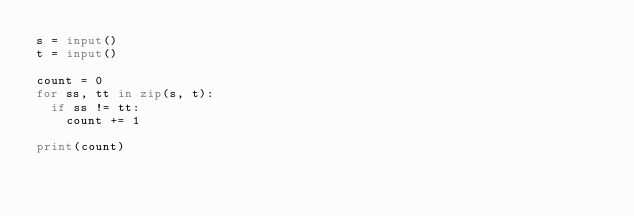Convert code to text. <code><loc_0><loc_0><loc_500><loc_500><_Python_>s = input()
t = input()

count = 0
for ss, tt in zip(s, t):
  if ss != tt:
    count += 1

print(count)</code> 